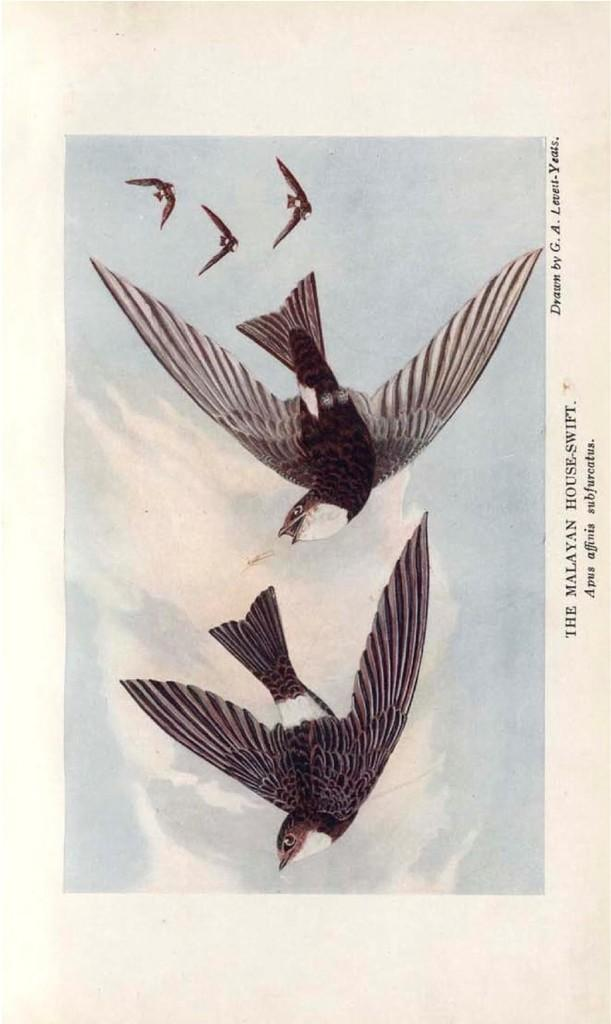What is the main subject of the poster in the image? The poster depicts birds flying. What can be seen in the background of the image? The sky is visible in the image, and clouds are present in the sky. Where is the text located in the image? The text is on the right side of the image. What type of nail is being hammered into the throat of the bird in the image? There is no nail or bird with a throat in the image; it features a poster of birds flying with text on the right side. 